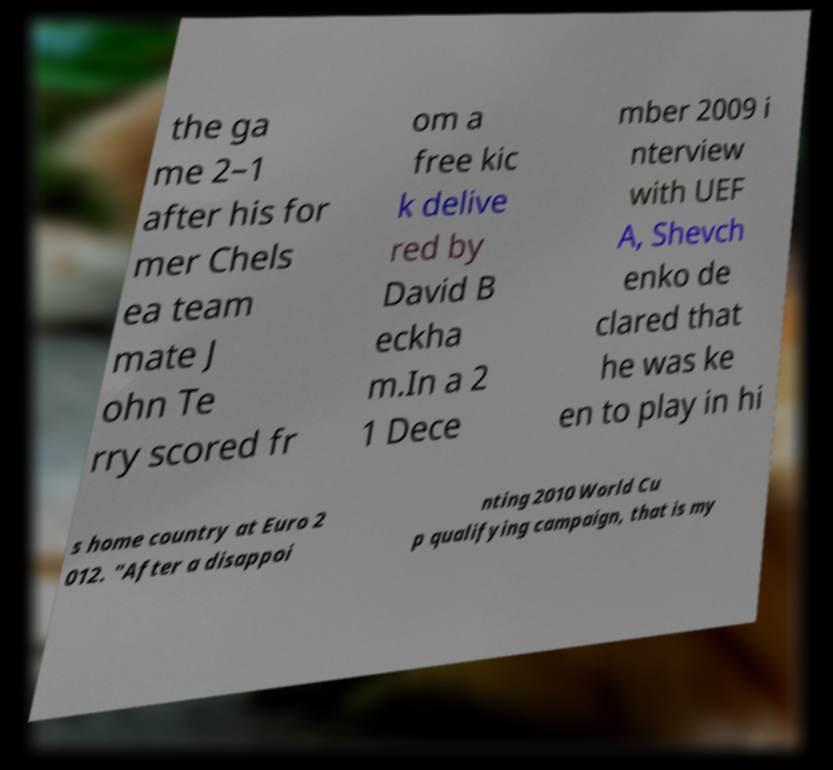Could you extract and type out the text from this image? the ga me 2–1 after his for mer Chels ea team mate J ohn Te rry scored fr om a free kic k delive red by David B eckha m.In a 2 1 Dece mber 2009 i nterview with UEF A, Shevch enko de clared that he was ke en to play in hi s home country at Euro 2 012. "After a disappoi nting 2010 World Cu p qualifying campaign, that is my 